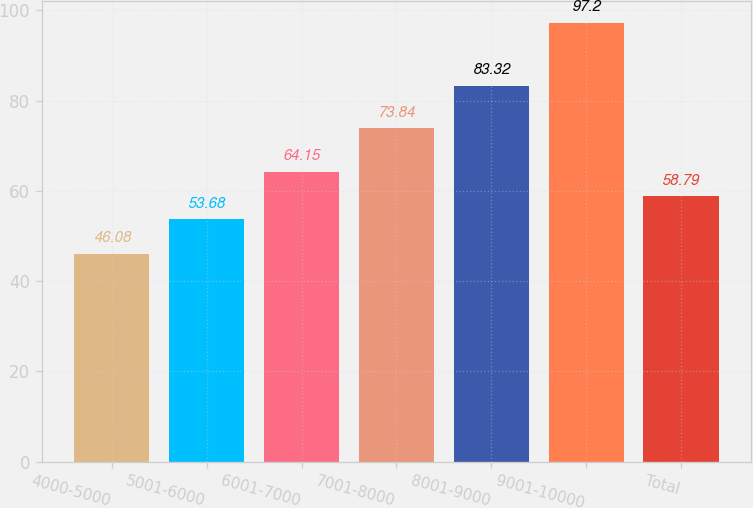Convert chart. <chart><loc_0><loc_0><loc_500><loc_500><bar_chart><fcel>4000-5000<fcel>5001-6000<fcel>6001-7000<fcel>7001-8000<fcel>8001-9000<fcel>9001-10000<fcel>Total<nl><fcel>46.08<fcel>53.68<fcel>64.15<fcel>73.84<fcel>83.32<fcel>97.2<fcel>58.79<nl></chart> 